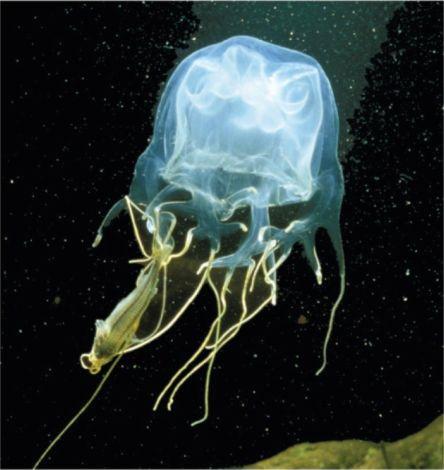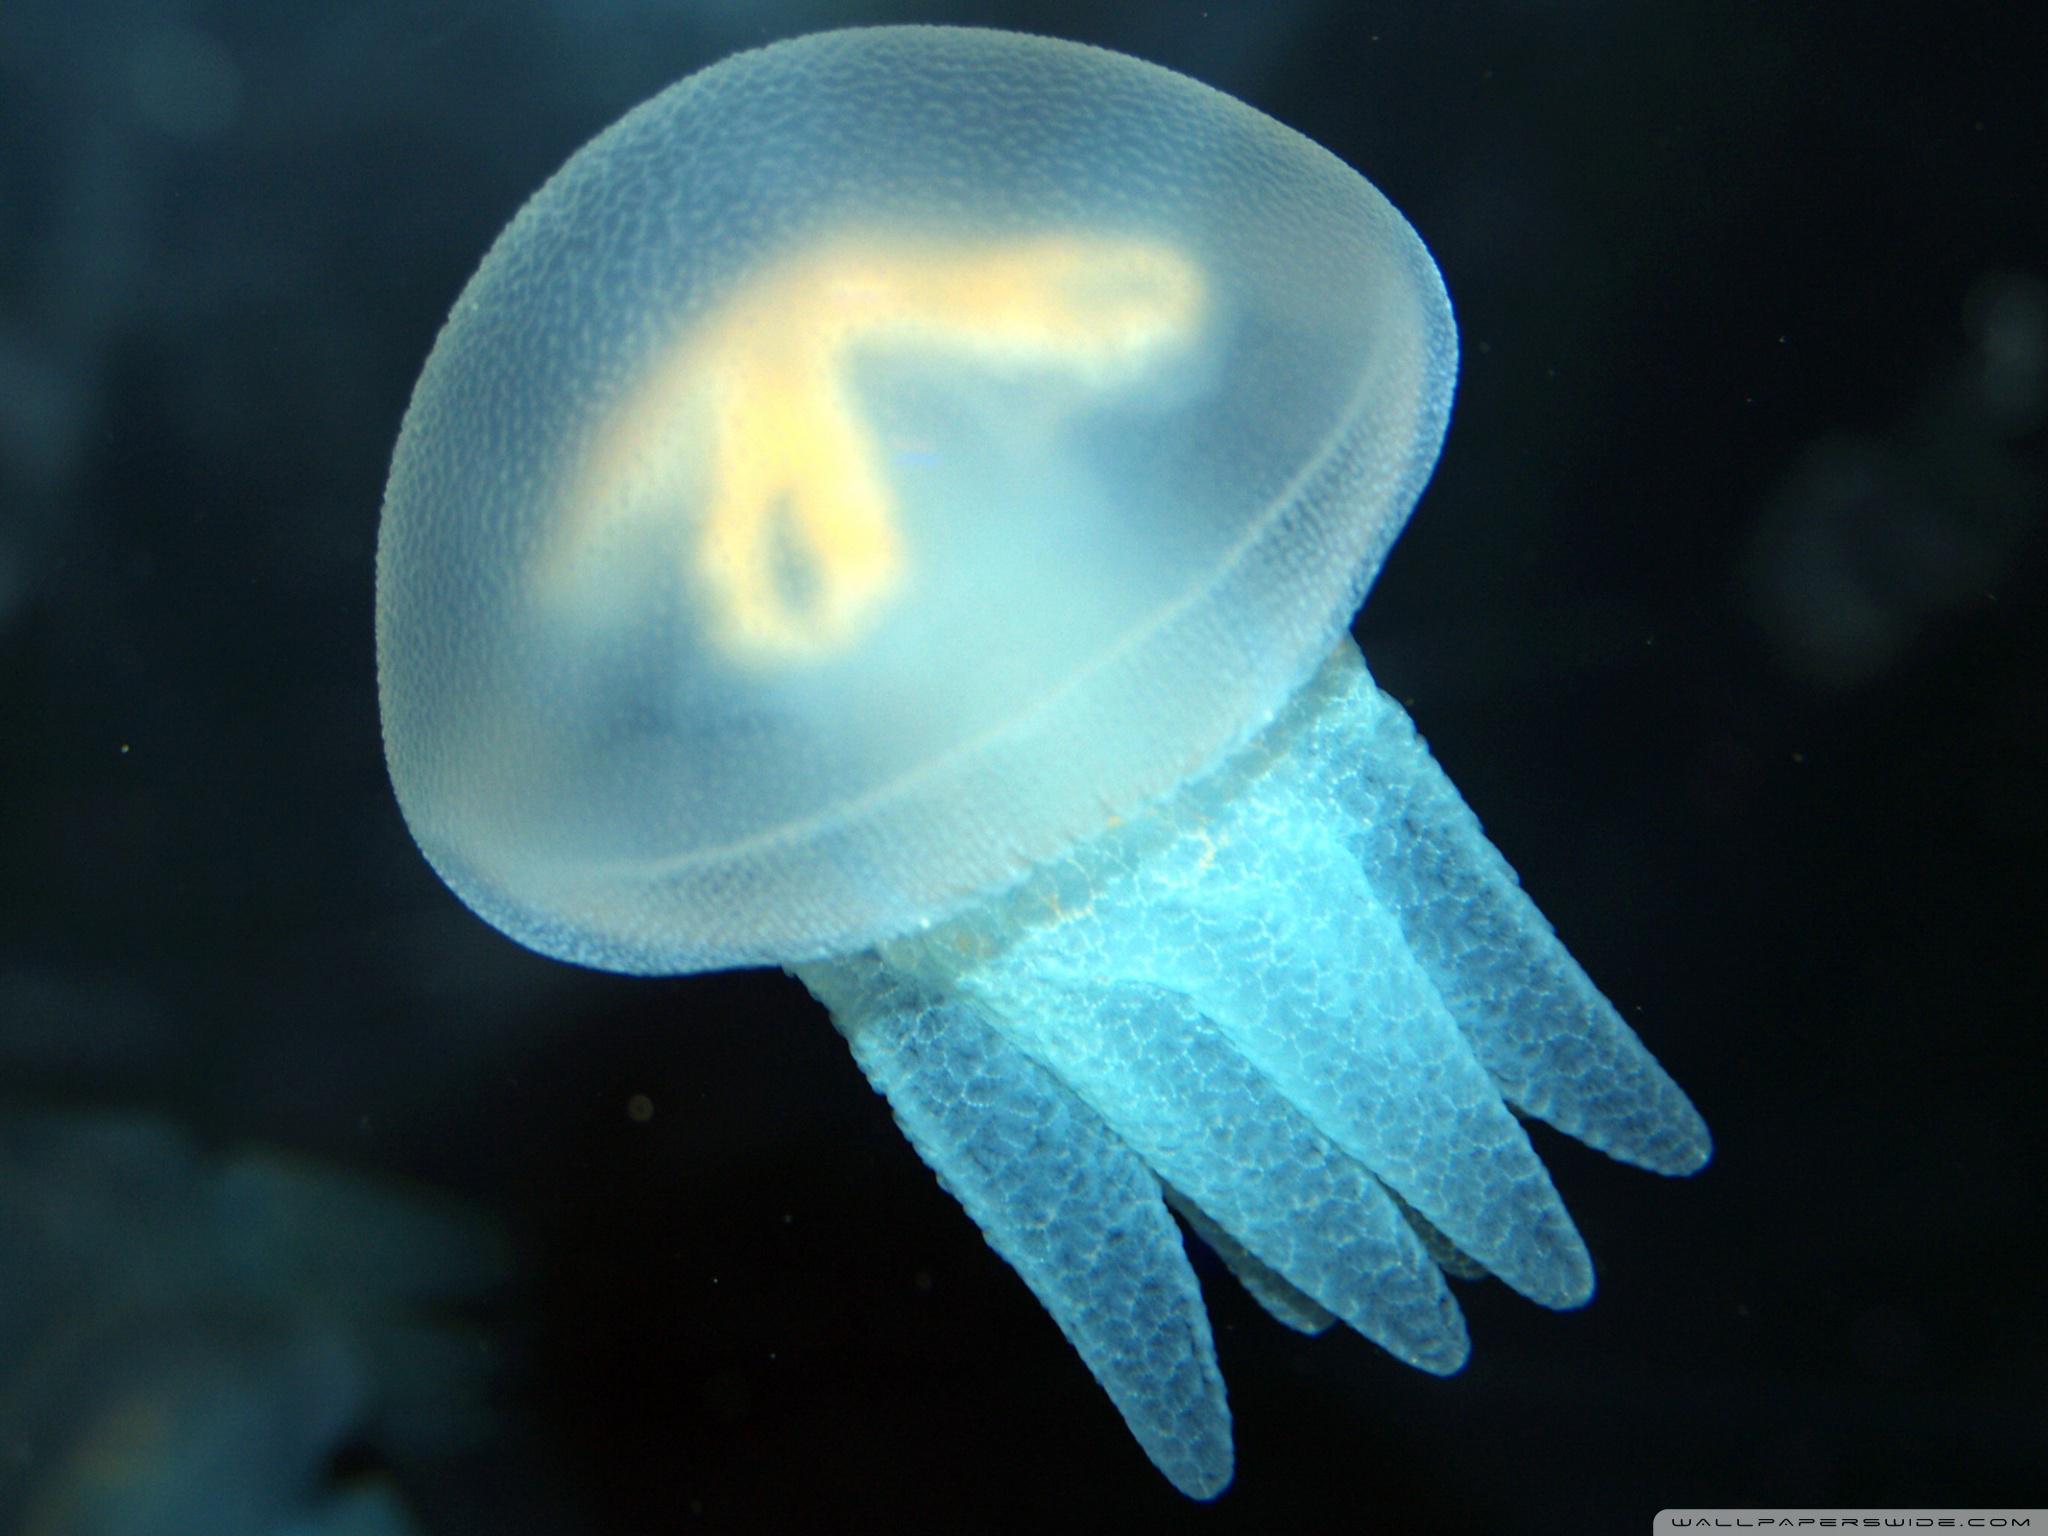The first image is the image on the left, the second image is the image on the right. Considering the images on both sides, is "The jellyfish is swimming to the left in the image on the left" valid? Answer yes or no. No. 